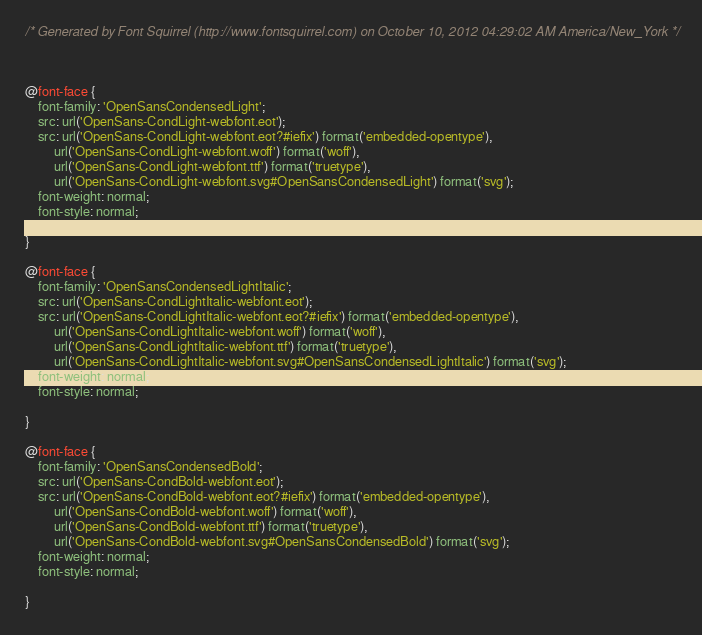Convert code to text. <code><loc_0><loc_0><loc_500><loc_500><_CSS_>/* Generated by Font Squirrel (http://www.fontsquirrel.com) on October 10, 2012 04:29:02 AM America/New_York */



@font-face {
    font-family: 'OpenSansCondensedLight';
    src: url('OpenSans-CondLight-webfont.eot');
    src: url('OpenSans-CondLight-webfont.eot?#iefix') format('embedded-opentype'),
         url('OpenSans-CondLight-webfont.woff') format('woff'),
         url('OpenSans-CondLight-webfont.ttf') format('truetype'),
         url('OpenSans-CondLight-webfont.svg#OpenSansCondensedLight') format('svg');
    font-weight: normal;
    font-style: normal;

}

@font-face {
    font-family: 'OpenSansCondensedLightItalic';
    src: url('OpenSans-CondLightItalic-webfont.eot');
    src: url('OpenSans-CondLightItalic-webfont.eot?#iefix') format('embedded-opentype'),
         url('OpenSans-CondLightItalic-webfont.woff') format('woff'),
         url('OpenSans-CondLightItalic-webfont.ttf') format('truetype'),
         url('OpenSans-CondLightItalic-webfont.svg#OpenSansCondensedLightItalic') format('svg');
    font-weight: normal;
    font-style: normal;

}

@font-face {
    font-family: 'OpenSansCondensedBold';
    src: url('OpenSans-CondBold-webfont.eot');
    src: url('OpenSans-CondBold-webfont.eot?#iefix') format('embedded-opentype'),
         url('OpenSans-CondBold-webfont.woff') format('woff'),
         url('OpenSans-CondBold-webfont.ttf') format('truetype'),
         url('OpenSans-CondBold-webfont.svg#OpenSansCondensedBold') format('svg');
    font-weight: normal;
    font-style: normal;

}

</code> 